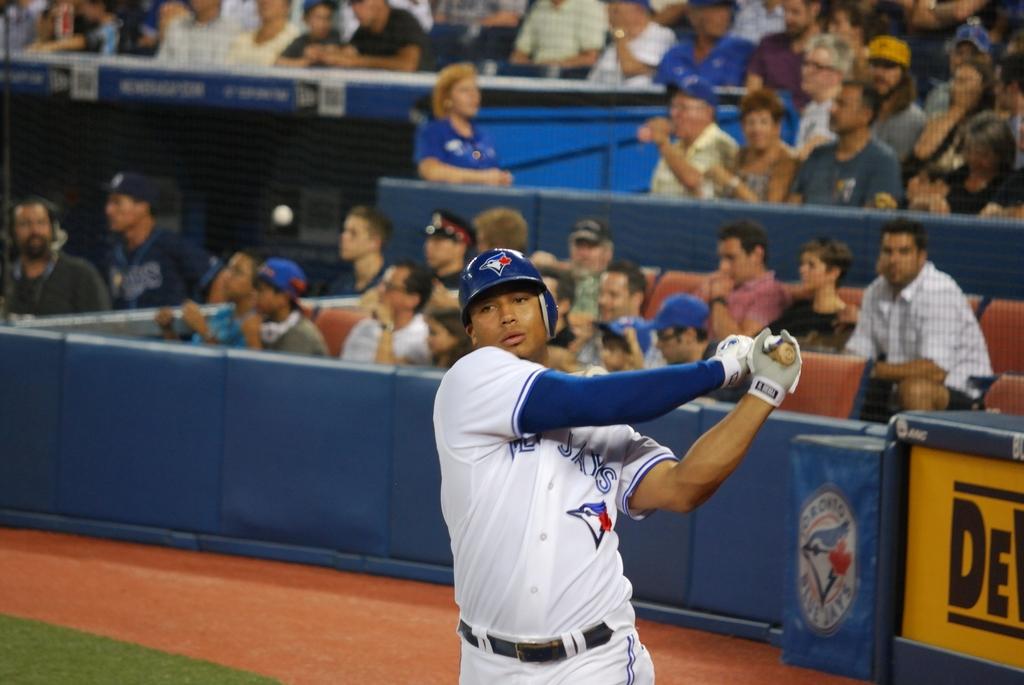What are the first two letters on the yellow sign?
Give a very brief answer. De. What team is playing?
Keep it short and to the point. Toronto blue jays. 